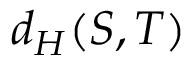Convert formula to latex. <formula><loc_0><loc_0><loc_500><loc_500>d _ { H } ( S , T )</formula> 